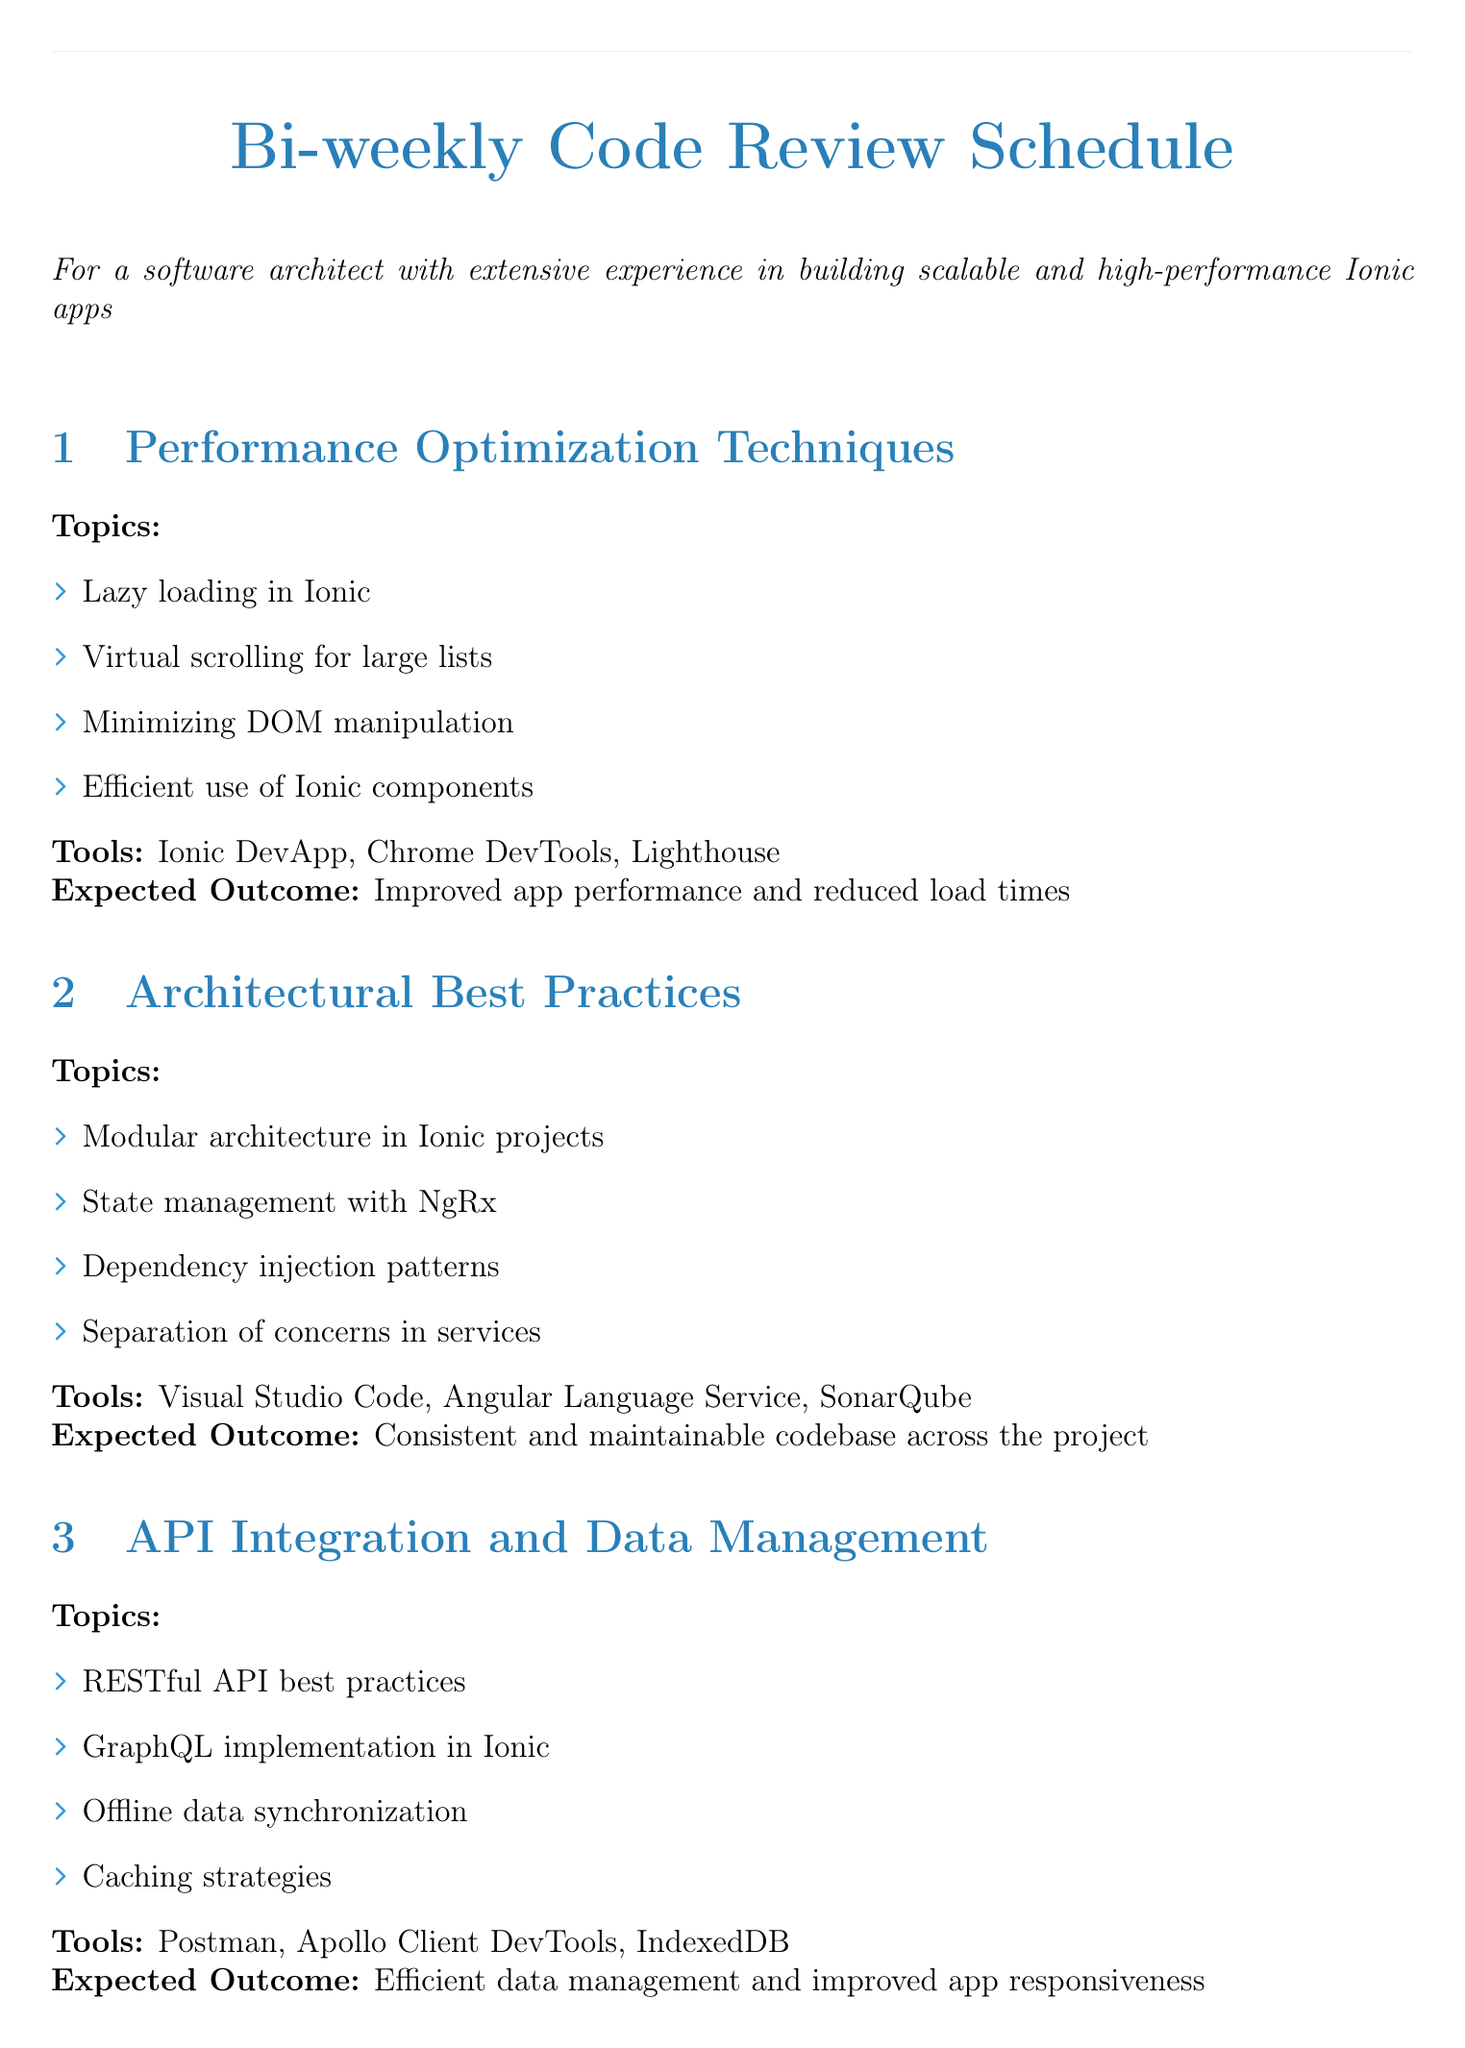What is the expected outcome of the Performance Optimization Techniques session? The expected outcome of this session is detailed in the document, which states it is "Improved app performance and reduced load times."
Answer: Improved app performance and reduced load times Which tool is used for API Integration and Data Management? The document lists multiple tools for this session, and one of them specified is "Postman."
Answer: Postman What topic covers the implementation of JWT in the security session? The document explicitly mentions "JWT implementation in Ionic" as a topic under Security and Authentication.
Answer: JWT implementation in Ionic How many topics are discussed in the Testing and Quality Assurance section? By counting the items listed in the document, there are four topics listed for this session.
Answer: Four What is the main focus of the Architectural Best Practices session? The document outlines various topics for this session, the main focus is described as "Consistent and maintainable codebase across the project."
Answer: Consistent and maintainable codebase across the project Which session discusses caching strategies? The session titled "API Integration and Data Management" addresses this topic according to the document.
Answer: API Integration and Data Management What is the title of the fifth session in the document? The document organizes sessions, and the fifth session is titled "Security and Authentication."
Answer: Security and Authentication What is one of the tools recommended for Continuous Integration and Deployment? The document lists tools for this session, including "Jenkins" as one of them.
Answer: Jenkins 